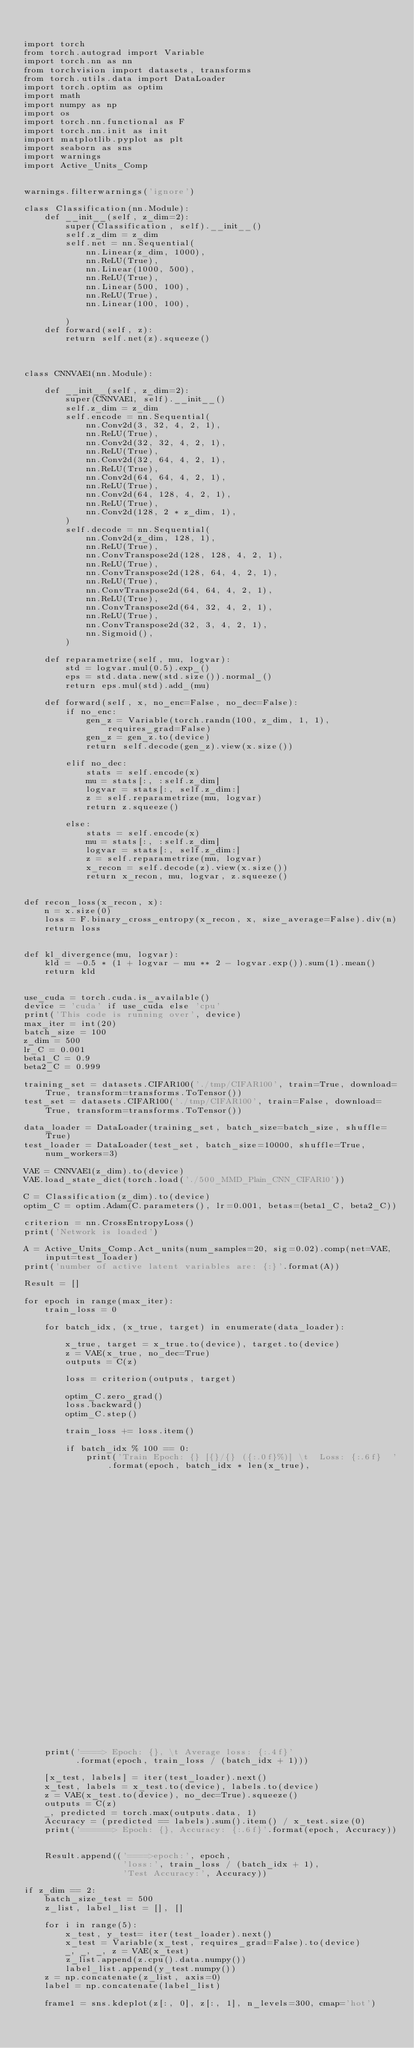Convert code to text. <code><loc_0><loc_0><loc_500><loc_500><_Python_>

import torch
from torch.autograd import Variable
import torch.nn as nn
from torchvision import datasets, transforms
from torch.utils.data import DataLoader
import torch.optim as optim
import math
import numpy as np
import os
import torch.nn.functional as F
import torch.nn.init as init
import matplotlib.pyplot as plt
import seaborn as sns
import warnings
import Active_Units_Comp


warnings.filterwarnings('ignore')

class Classification(nn.Module):
    def __init__(self, z_dim=2):
        super(Classification, self).__init__()
        self.z_dim = z_dim
        self.net = nn.Sequential(
            nn.Linear(z_dim, 1000),
            nn.ReLU(True),
            nn.Linear(1000, 500),
            nn.ReLU(True),
            nn.Linear(500, 100),
            nn.ReLU(True),
            nn.Linear(100, 100),

        )
    def forward(self, z):
        return self.net(z).squeeze()



class CNNVAE1(nn.Module):

    def __init__(self, z_dim=2):
        super(CNNVAE1, self).__init__()
        self.z_dim = z_dim
        self.encode = nn.Sequential(
            nn.Conv2d(3, 32, 4, 2, 1),
            nn.ReLU(True),
            nn.Conv2d(32, 32, 4, 2, 1),
            nn.ReLU(True),
            nn.Conv2d(32, 64, 4, 2, 1),
            nn.ReLU(True),
            nn.Conv2d(64, 64, 4, 2, 1),
            nn.ReLU(True),
            nn.Conv2d(64, 128, 4, 2, 1),
            nn.ReLU(True),
            nn.Conv2d(128, 2 * z_dim, 1),
        )
        self.decode = nn.Sequential(
            nn.Conv2d(z_dim, 128, 1),
            nn.ReLU(True),
            nn.ConvTranspose2d(128, 128, 4, 2, 1),
            nn.ReLU(True),
            nn.ConvTranspose2d(128, 64, 4, 2, 1),
            nn.ReLU(True),
            nn.ConvTranspose2d(64, 64, 4, 2, 1),
            nn.ReLU(True),
            nn.ConvTranspose2d(64, 32, 4, 2, 1),
            nn.ReLU(True),
            nn.ConvTranspose2d(32, 3, 4, 2, 1),
            nn.Sigmoid(),
        )

    def reparametrize(self, mu, logvar):
        std = logvar.mul(0.5).exp_()
        eps = std.data.new(std.size()).normal_()
        return eps.mul(std).add_(mu)

    def forward(self, x, no_enc=False, no_dec=False):
        if no_enc:
            gen_z = Variable(torch.randn(100, z_dim, 1, 1), requires_grad=False)
            gen_z = gen_z.to(device)
            return self.decode(gen_z).view(x.size())

        elif no_dec:
            stats = self.encode(x)
            mu = stats[:, :self.z_dim]
            logvar = stats[:, self.z_dim:]
            z = self.reparametrize(mu, logvar)
            return z.squeeze()

        else:
            stats = self.encode(x)
            mu = stats[:, :self.z_dim]
            logvar = stats[:, self.z_dim:]
            z = self.reparametrize(mu, logvar)
            x_recon = self.decode(z).view(x.size())
            return x_recon, mu, logvar, z.squeeze()


def recon_loss(x_recon, x):
    n = x.size(0)
    loss = F.binary_cross_entropy(x_recon, x, size_average=False).div(n)
    return loss


def kl_divergence(mu, logvar):
    kld = -0.5 * (1 + logvar - mu ** 2 - logvar.exp()).sum(1).mean()
    return kld


use_cuda = torch.cuda.is_available()
device = 'cuda' if use_cuda else 'cpu'
print('This code is running over', device)
max_iter = int(20)
batch_size = 100
z_dim = 500
lr_C = 0.001
beta1_C = 0.9
beta2_C = 0.999

training_set = datasets.CIFAR100('./tmp/CIFAR100', train=True, download=True, transform=transforms.ToTensor())
test_set = datasets.CIFAR100('./tmp/CIFAR100', train=False, download=True, transform=transforms.ToTensor())

data_loader = DataLoader(training_set, batch_size=batch_size, shuffle=True)
test_loader = DataLoader(test_set, batch_size=10000, shuffle=True, num_workers=3)

VAE = CNNVAE1(z_dim).to(device)
VAE.load_state_dict(torch.load('./500_MMD_Plain_CNN_CIFAR10'))

C = Classification(z_dim).to(device)
optim_C = optim.Adam(C.parameters(), lr=0.001, betas=(beta1_C, beta2_C))

criterion = nn.CrossEntropyLoss()
print('Network is loaded')

A = Active_Units_Comp.Act_units(num_samples=20, sig=0.02).comp(net=VAE, input=test_loader)
print('number of active latent variables are: {:}'.format(A))

Result = []

for epoch in range(max_iter):
    train_loss = 0

    for batch_idx, (x_true, target) in enumerate(data_loader):

        x_true, target = x_true.to(device), target.to(device)
        z = VAE(x_true, no_dec=True)
        outputs = C(z)

        loss = criterion(outputs, target)

        optim_C.zero_grad()
        loss.backward()
        optim_C.step()

        train_loss += loss.item()

        if batch_idx % 100 == 0:
            print('Train Epoch: {} [{}/{} ({:.0f}%)] \t  Loss: {:.6f}  '.format(epoch, batch_idx * len(x_true),
                                                                              len(data_loader.dataset),
                                                                              100. * batch_idx / len(data_loader),
                                                                              loss.item(),
                                                                                            ))

    print('====> Epoch: {}, \t Average loss: {:.4f}'
          .format(epoch, train_loss / (batch_idx + 1)))

    [x_test, labels] = iter(test_loader).next()
    x_test, labels = x_test.to(device), labels.to(device)
    z = VAE(x_test.to(device), no_dec=True).squeeze()
    outputs = C(z)
    _, predicted = torch.max(outputs.data, 1)
    Accuracy = (predicted == labels).sum().item() / x_test.size(0)
    print('======> Epoch: {}, Accuracy: {:.6f}'.format(epoch, Accuracy))


    Result.append(('====>epoch:', epoch,
                   'loss:', train_loss / (batch_idx + 1),
                   'Test Accuracy:', Accuracy))

if z_dim == 2:
    batch_size_test = 500
    z_list, label_list = [], []

    for i in range(5):
        x_test, y_test= iter(test_loader).next()
        x_test = Variable(x_test, requires_grad=False).to(device)
        _, _, _, z = VAE(x_test)
        z_list.append(z.cpu().data.numpy())
        label_list.append(y_test.numpy())
    z = np.concatenate(z_list, axis=0)
    label = np.concatenate(label_list)

    frame1 = sns.kdeplot(z[:, 0], z[:, 1], n_levels=300, cmap='hot')</code> 